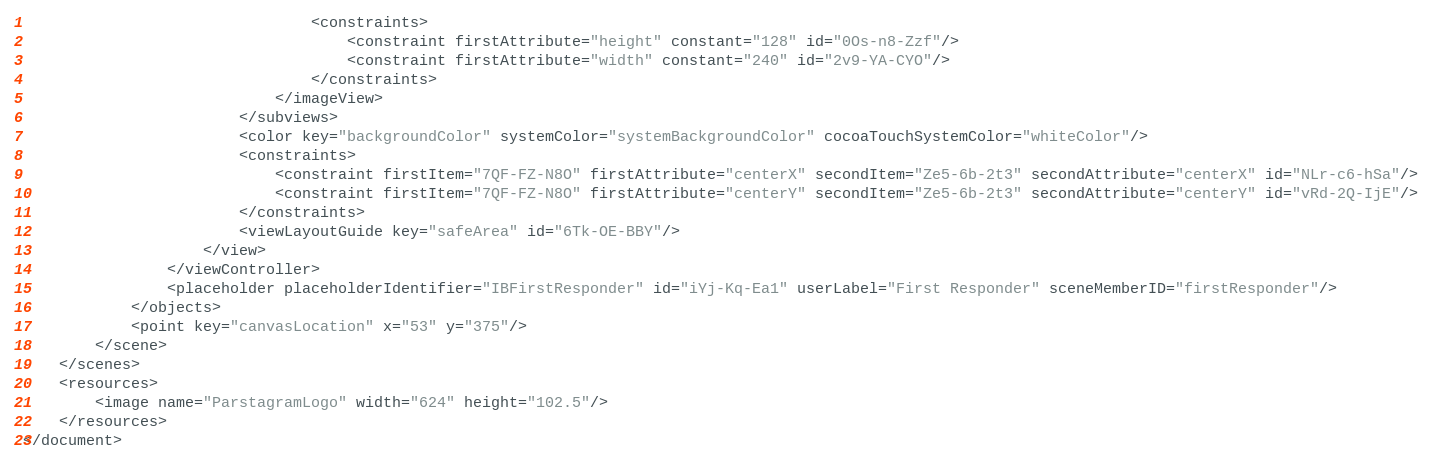Convert code to text. <code><loc_0><loc_0><loc_500><loc_500><_XML_>                                <constraints>
                                    <constraint firstAttribute="height" constant="128" id="0Os-n8-Zzf"/>
                                    <constraint firstAttribute="width" constant="240" id="2v9-YA-CYO"/>
                                </constraints>
                            </imageView>
                        </subviews>
                        <color key="backgroundColor" systemColor="systemBackgroundColor" cocoaTouchSystemColor="whiteColor"/>
                        <constraints>
                            <constraint firstItem="7QF-FZ-N8O" firstAttribute="centerX" secondItem="Ze5-6b-2t3" secondAttribute="centerX" id="NLr-c6-hSa"/>
                            <constraint firstItem="7QF-FZ-N8O" firstAttribute="centerY" secondItem="Ze5-6b-2t3" secondAttribute="centerY" id="vRd-2Q-IjE"/>
                        </constraints>
                        <viewLayoutGuide key="safeArea" id="6Tk-OE-BBY"/>
                    </view>
                </viewController>
                <placeholder placeholderIdentifier="IBFirstResponder" id="iYj-Kq-Ea1" userLabel="First Responder" sceneMemberID="firstResponder"/>
            </objects>
            <point key="canvasLocation" x="53" y="375"/>
        </scene>
    </scenes>
    <resources>
        <image name="ParstagramLogo" width="624" height="102.5"/>
    </resources>
</document>
</code> 